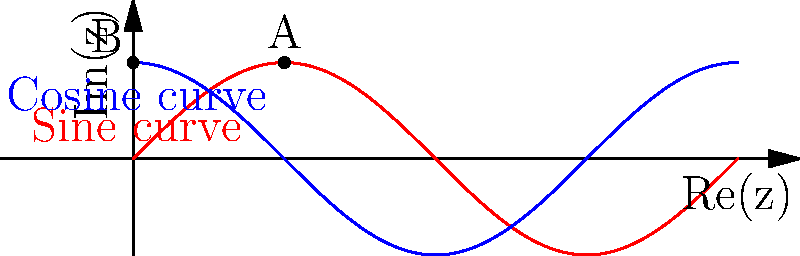In the context of developing a new reality TV game concept inspired by Riemann surfaces, consider the graph above representing two complex-valued functions on a portion of the complex plane. How could this representation be used to create a challenging navigation task for contestants, and what unique element of Riemann surfaces does it showcase that could make for compelling television? To answer this question, let's break it down step-by-step:

1. The graph shows two curves: a sine curve (in red) and a cosine curve (in blue) plotted on the complex plane.

2. These curves can be thought of as representations of complex-valued functions, where:
   - The x-axis represents the real part (Re(z))
   - The y-axis represents the imaginary part (Im(z))

3. In terms of Riemann surfaces, these curves can be seen as projections of paths on a multi-sheeted surface onto the complex plane.

4. A key feature of Riemann surfaces is that they allow for the continuous extension of multi-valued functions, such as complex logarithms or square roots.

5. For a reality TV game concept, we could create a challenge where contestants must:
   a) Navigate along these curves in a virtual 3D space
   b) Switch between different "sheets" of the Riemann surface at specific points

6. The unique element showcased here is the concept of analytic continuation, where a function can be extended beyond its original domain in a unique way.

7. This could make for compelling television because:
   a) It provides a visually interesting 3D environment for contestants to navigate
   b) It introduces a mind-bending concept (moving between sheets of a surface) that can be dramatized
   c) It allows for strategic thinking in choosing paths and transition points

8. The points A and B on the graph could represent key locations where contestants can transition between sheets or face challenges.

9. The game could involve tasks like collecting items, avoiding obstacles, or racing against time while navigating this complex mathematical landscape.

This concept combines the visual appeal of complex geometries with the strategic elements of navigation and decision-making, potentially creating an engaging and unique reality TV game show.
Answer: Navigate complex curves as sheets of a Riemann surface, showcasing analytic continuation in a 3D virtual environment. 